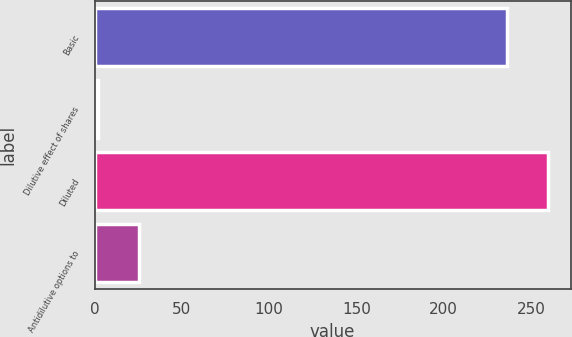<chart> <loc_0><loc_0><loc_500><loc_500><bar_chart><fcel>Basic<fcel>Dilutive effect of shares<fcel>Diluted<fcel>Antidilutive options to<nl><fcel>236.1<fcel>1.7<fcel>259.71<fcel>25.31<nl></chart> 